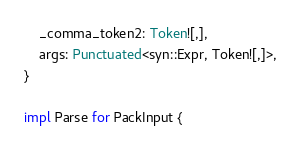<code> <loc_0><loc_0><loc_500><loc_500><_Rust_>    _comma_token2: Token![,],
    args: Punctuated<syn::Expr, Token![,]>,
}

impl Parse for PackInput {</code> 